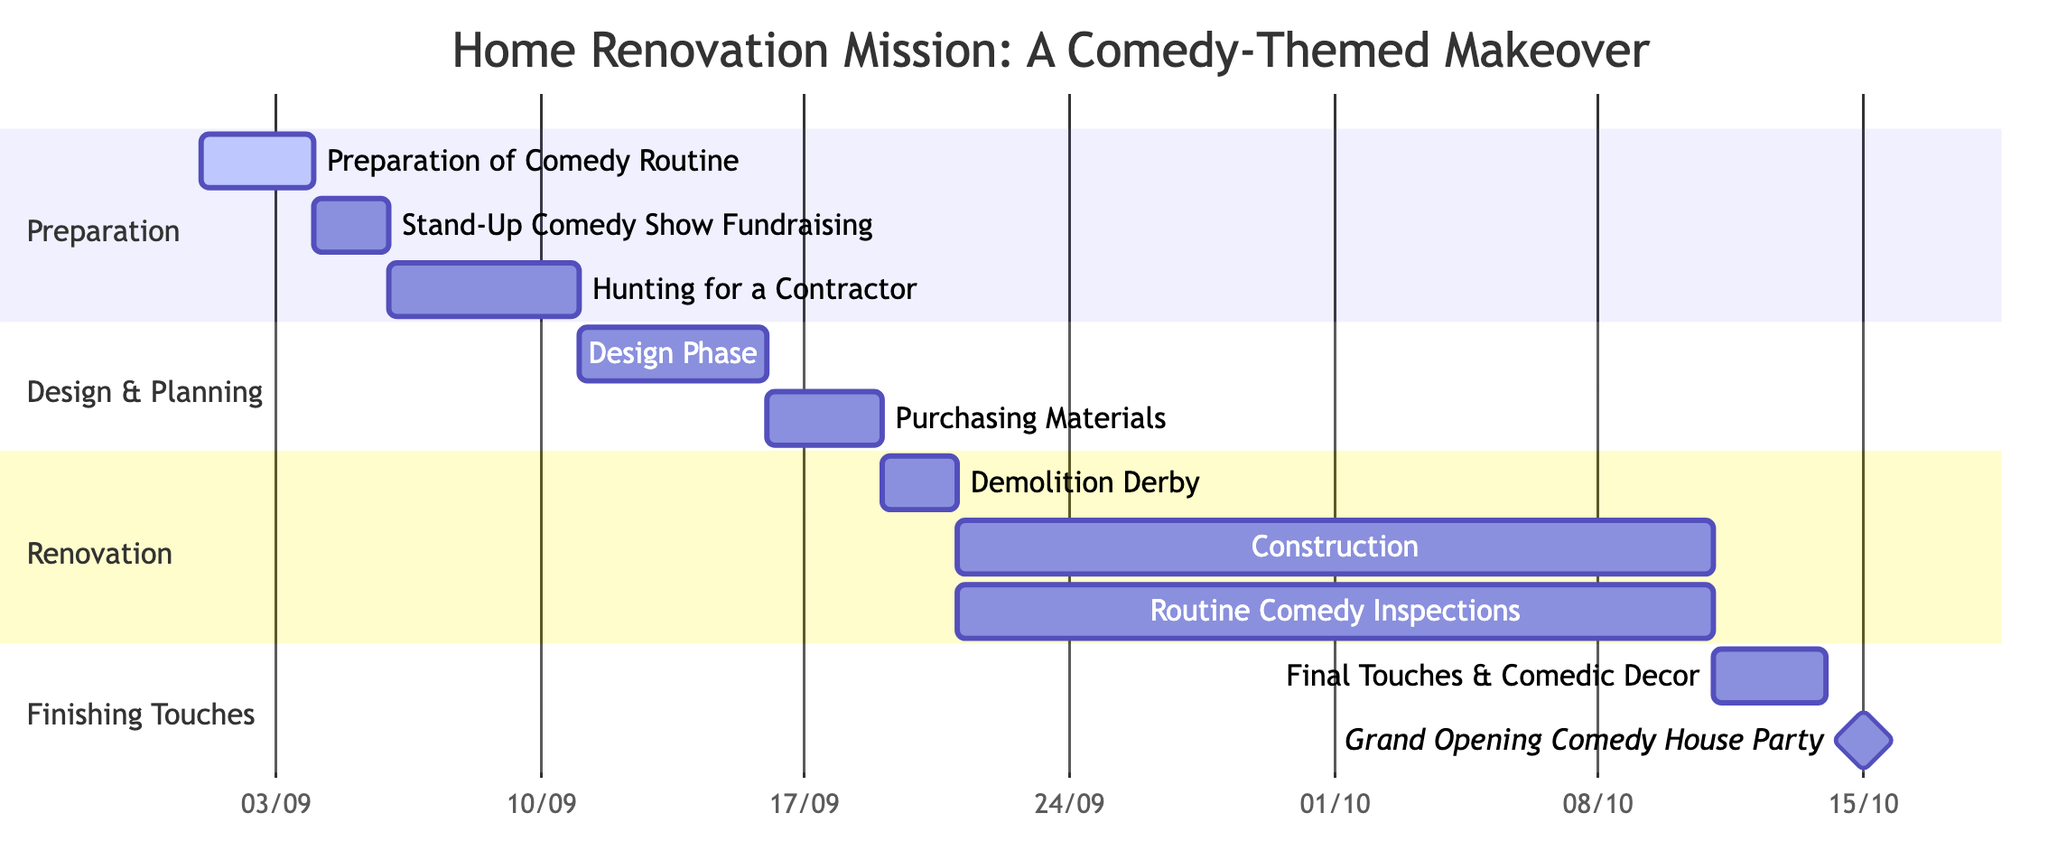What is the duration of the "Construction: Joke after Joke" task? The "Construction: Joke after Joke" task starts on September 21, 2023, and ends on October 10, 2023. To calculate the duration, count the days from start to end inclusive, which is 20 days.
Answer: 20 days Which task comes immediately after "Design Phase: Comedy-Infused Ideas"? The "Purchasing Materials: Comedy-Store Style" task is directly after "Design Phase: Comedy-Infused Ideas", occurring right after it finishes. "Design Phase" ends on September 15, and "Purchasing Materials" starts on September 16.
Answer: Purchasing Materials: Comedy-Store Style How many tasks are in the "Renovation" section? The "Renovation" section contains three tasks: "Demolition Derby: House Edition," "Construction: Joke after Joke," and "Routine Comedy Inspections." Counting these tasks gives us a total of three.
Answer: 3 Which task has a dependency on "Stand-Up Comedy Show Fundraising"? The task that is dependent on "Stand-Up Comedy Show Fundraising" is "Hunting for a Contractor: The Audition." This relationship shows that the hunting can only begin once the fundraising is complete.
Answer: Hunting for a Contractor: The Audition What is the start date of the "Final Touches & Comedic Decor" task? The "Final Touches & Comedic Decor" task begins on October 11, 2023. This is directly indicated in the Gantt chart under the section "Finishing Touches."
Answer: October 11, 2023 Which task is labeled as a milestone? The task labeled as a milestone is "Grand Opening Comedy House Party." This signifies it as a key event and completion point in the renovation process.
Answer: Grand Opening Comedy House Party What two tasks run simultaneously from September 21 to October 10? The two tasks that run simultaneously are "Construction: Joke after Joke" and "Routine Comedy Inspections." Both tasks start on September 21 and last until October 10, indicating they occur in parallel during this phase.
Answer: Construction: Joke after Joke and Routine Comedy Inspections What is the end date for the "Stand-Up Comedy Show Fundraising" task? The "Stand-Up Comedy Show Fundraising" task ends on September 5, 2023. The duration of the task is two days, starting from September 4.
Answer: September 5, 2023 